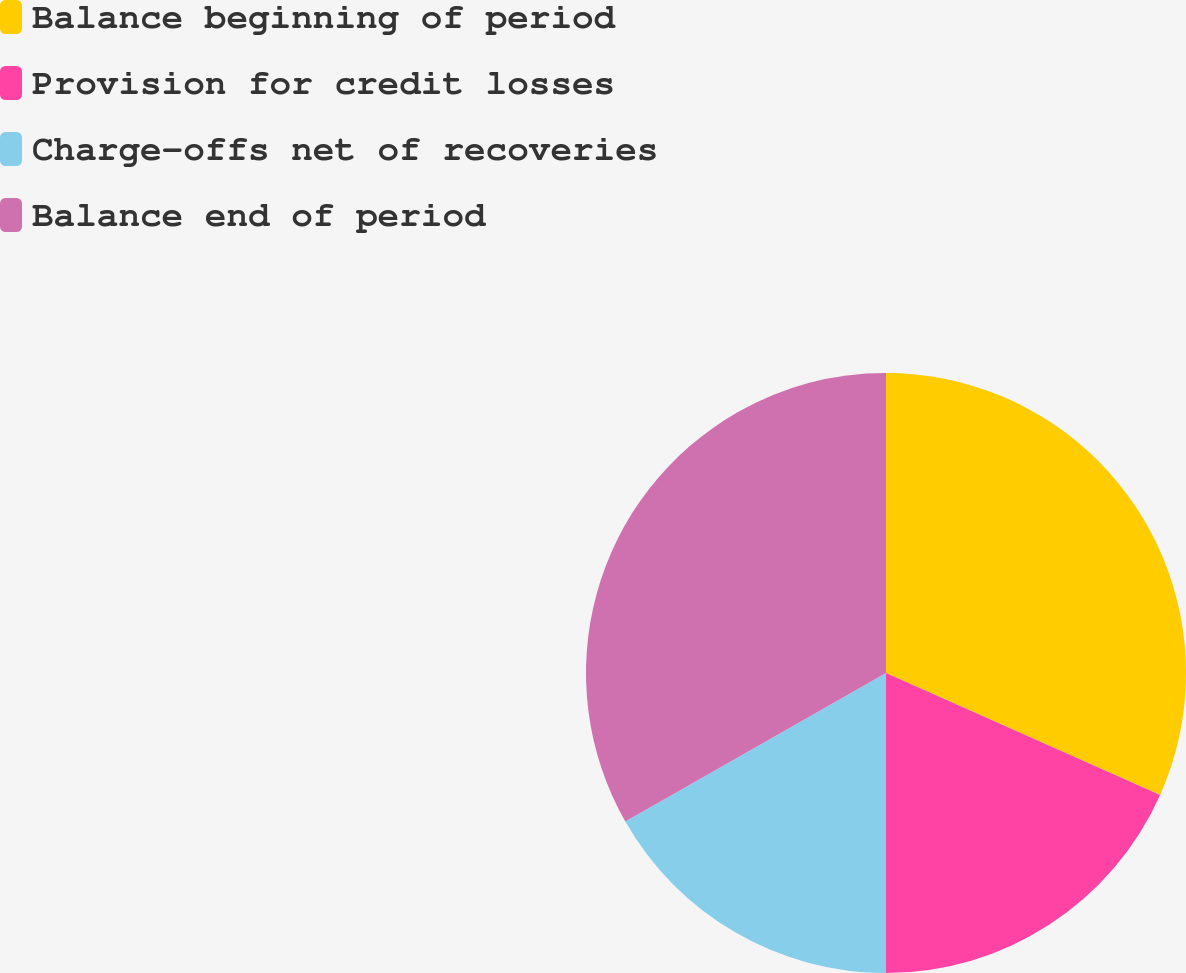Convert chart. <chart><loc_0><loc_0><loc_500><loc_500><pie_chart><fcel>Balance beginning of period<fcel>Provision for credit losses<fcel>Charge-offs net of recoveries<fcel>Balance end of period<nl><fcel>31.66%<fcel>18.34%<fcel>16.76%<fcel>33.24%<nl></chart> 